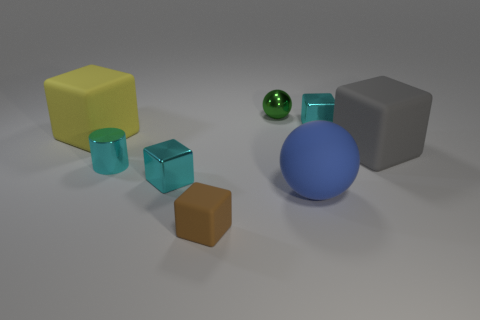How many metallic things have the same size as the cyan cylinder?
Offer a terse response. 3. What is the material of the big blue sphere?
Make the answer very short. Rubber. Is the number of tiny brown rubber cubes greater than the number of shiny cubes?
Your answer should be very brief. No. Do the green object and the yellow rubber thing have the same shape?
Keep it short and to the point. No. Are there any other things that have the same shape as the brown rubber thing?
Give a very brief answer. Yes. Do the metal cube that is behind the cyan shiny cylinder and the tiny metallic cube in front of the big yellow matte object have the same color?
Your response must be concise. Yes. Is the number of big gray objects left of the big yellow thing less than the number of large blue balls left of the tiny green sphere?
Ensure brevity in your answer.  No. There is a small cyan metallic object in front of the small metallic cylinder; what is its shape?
Give a very brief answer. Cube. How many other things are there of the same material as the gray block?
Offer a terse response. 3. Do the blue rubber thing and the small cyan metallic thing behind the yellow block have the same shape?
Your answer should be compact. No. 